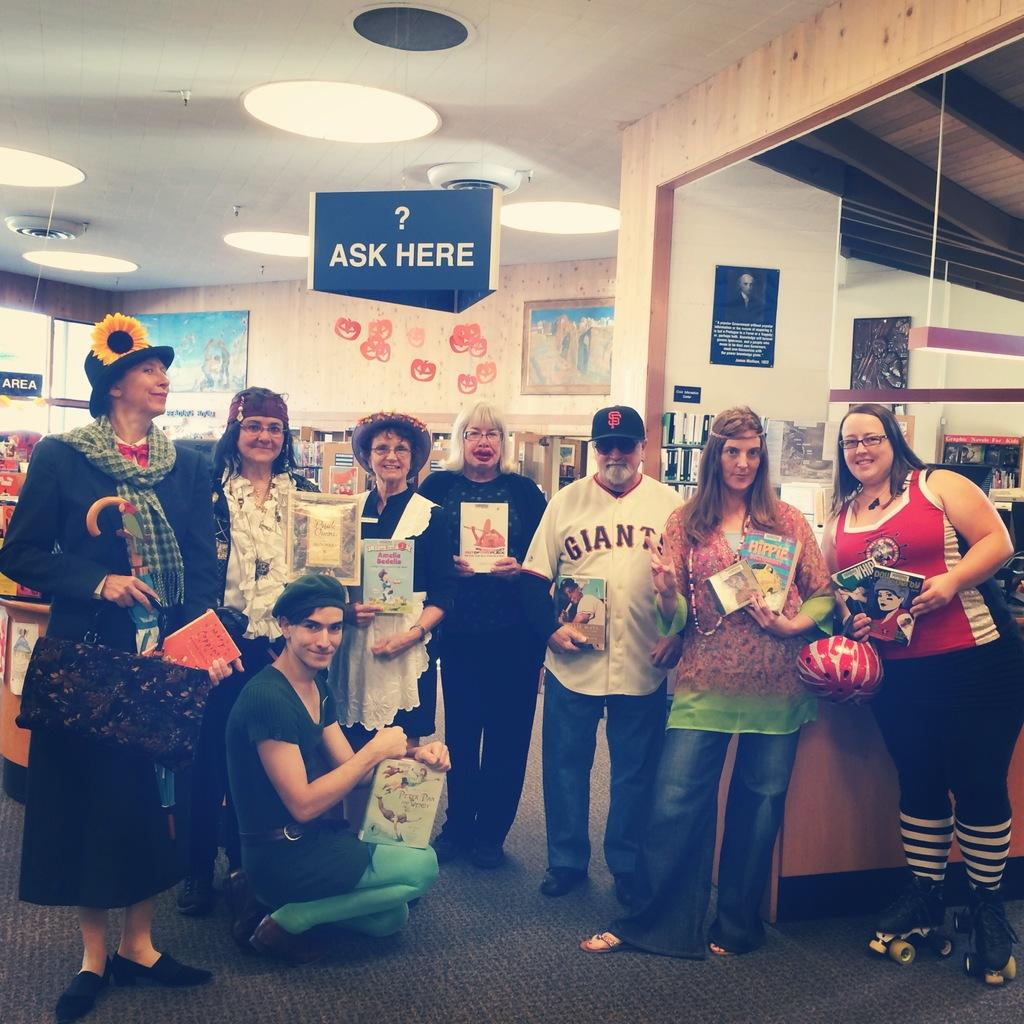<image>
Offer a succinct explanation of the picture presented. A group of people stand under a sign saying ask here. 